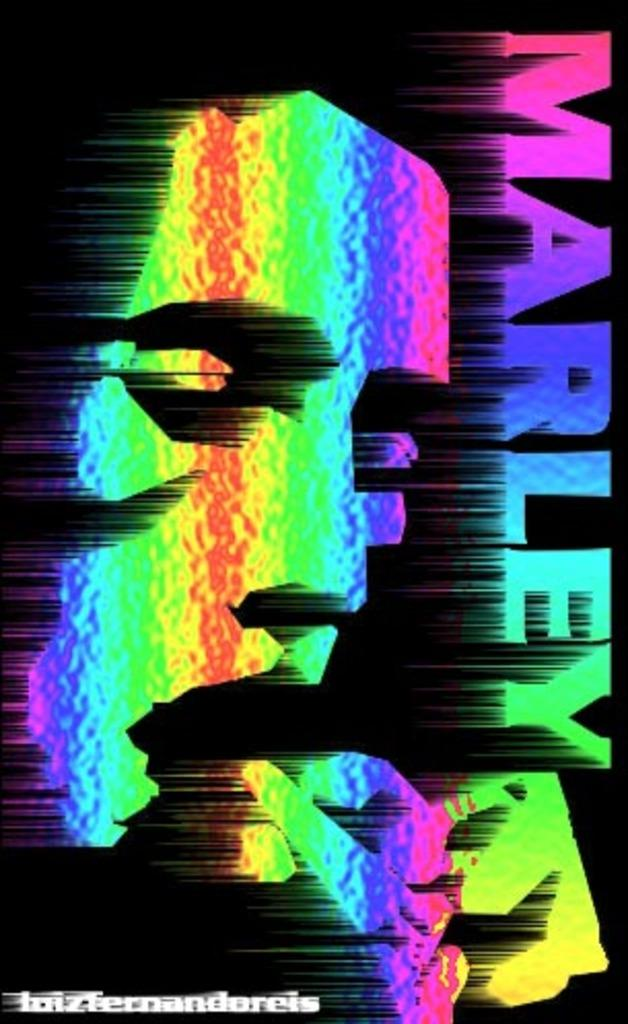What type of image is being described? The image is animated. Are there any words or letters in the image? Yes, there is text in the image. Is there anything else notable about the image? There is another image within the main image. What type of substance is causing the earthquake in the image? There is no earthquake present in the image. On what stage is the image being displayed? The image is not being displayed on a stage; it is a still image or animation. 